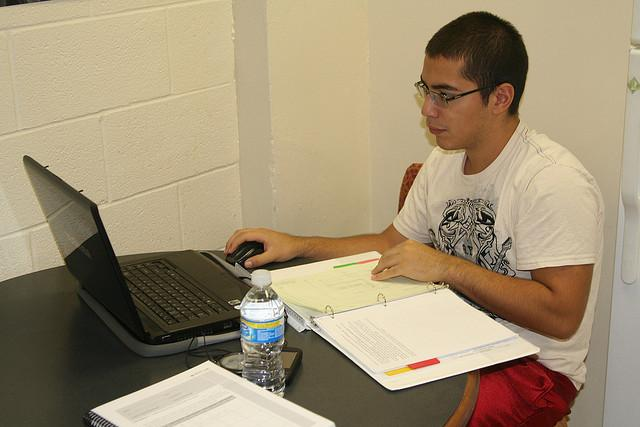Where is this student studying? table 